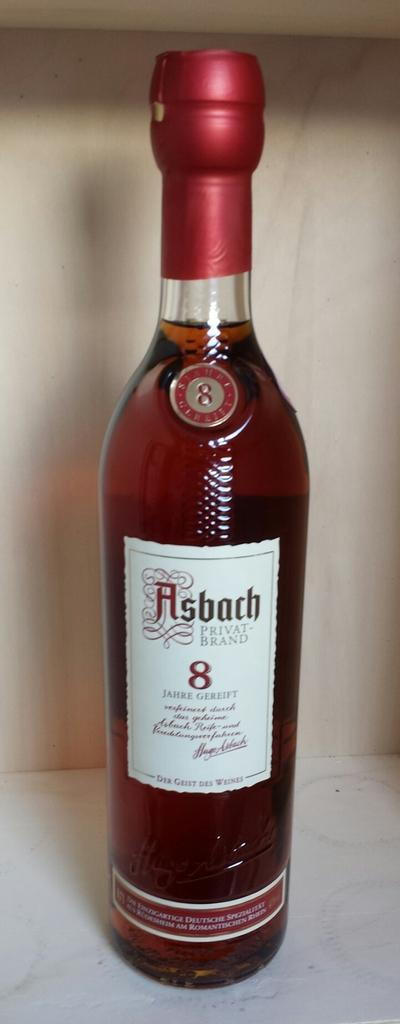<image>
Share a concise interpretation of the image provided. ASbach Private-brand is pictured against a wooden shelf 